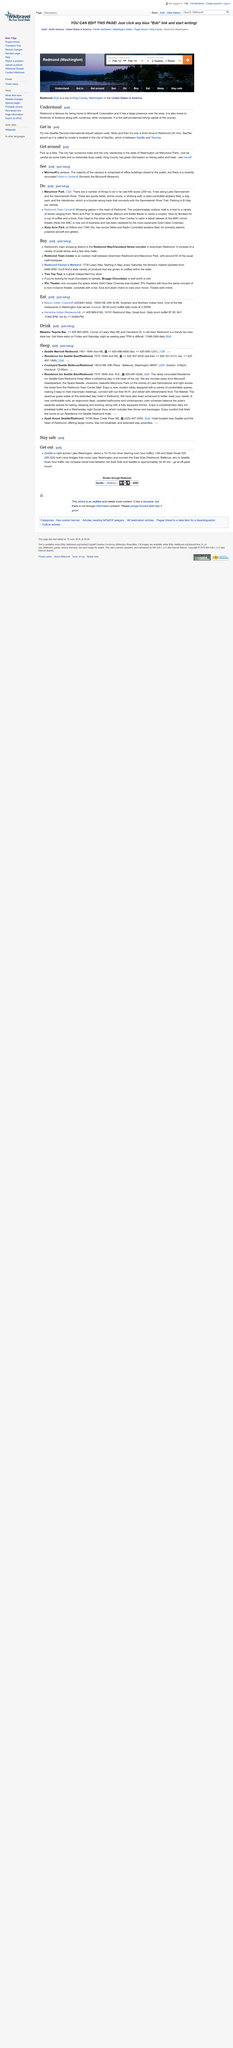Point out several critical features in this image. Seattle-Tacoma International Airport's airport code is SEA. There is only one velodrome located in the state of Washington, and it is the site of the How Many Velodromes Are In The State Of Washington? question, which is asking about the number of velodromes in the state of Washington. It is a 30-minute drive from SeaTac Airport to the Microsoft Corporation. 